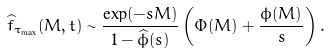<formula> <loc_0><loc_0><loc_500><loc_500>\widehat { f } _ { \tau _ { \max } } ( M , t ) \sim \frac { \exp ( - s M ) } { 1 - \widehat { \phi } ( s ) } \left ( \Phi ( M ) + \frac { \phi ( M ) } { s } \right ) .</formula> 